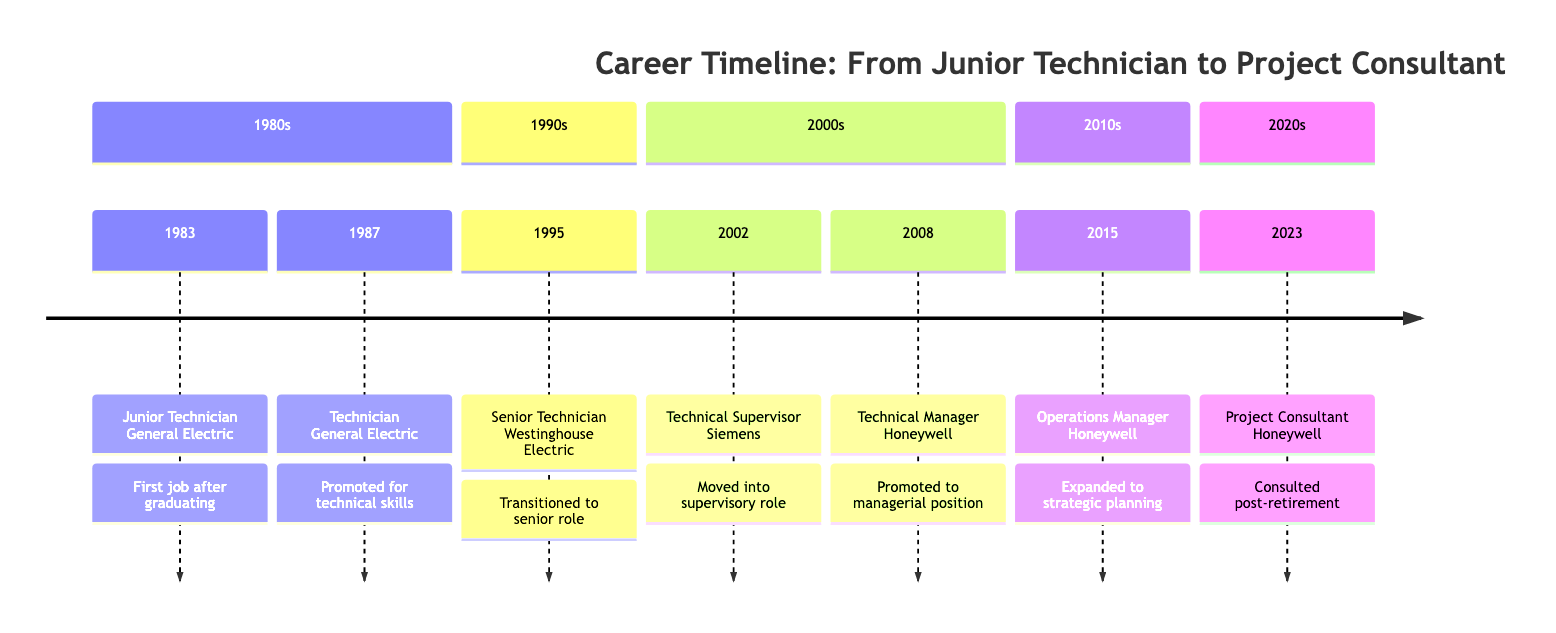What was your first job title? The timeline indicates that the first job title is "Junior Technician," which is listed under the year 1983.
Answer: Junior Technician Which company did you work for in 1995? The timeline shows that in 1995, the role was with "Westinghouse Electric." This can be seen in the node for the year 1995.
Answer: Westinghouse Electric What was the milestone for the role of Technical Supervisor? The timeline notes that the milestone for "Technical Supervisor" in 2002 is "Moved into a supervisory role." This is a direct citation from the diagram.
Answer: Moved into a supervisory role How many distinct job roles did you have by 2023? By counting the roles listed in the timeline from 1983 to 2023, there are seven distinct roles mentioned. This is calculated by listing each role chronologically.
Answer: 7 Which role involved overseeing major repair projects? Referring to the timeline, "Senior Technician" in 1995 is noted for "Oversaw major repair projects," indicating the specific responsibilities in that role.
Answer: Senior Technician Which two roles were held at Honeywell? By reviewing the roles listed in the timeline, the two roles held at Honeywell are "Technical Manager" (2008) and "Operations Manager" (2015). This is deduced from the company listed in conjunction with the specific years.
Answer: Technical Manager, Operations Manager What year did you become a Project Consultant? The timeline specifies that the role of "Project Consultant" was taken in the year 2023, marked clearly on the timeline.
Answer: 2023 What milestone describes your transition into a managerial position? The timeline states that the milestone for the role of "Technical Manager" in 2008 was "Promoted to a managerial position." Hence, this reflects the transition into management.
Answer: Promoted to a managerial position What was your role in 2002? From the timeline, the role in 2002 is listed as "Technical Supervisor." This is straightforward as it is directly stated in that year’s entry.
Answer: Technical Supervisor 